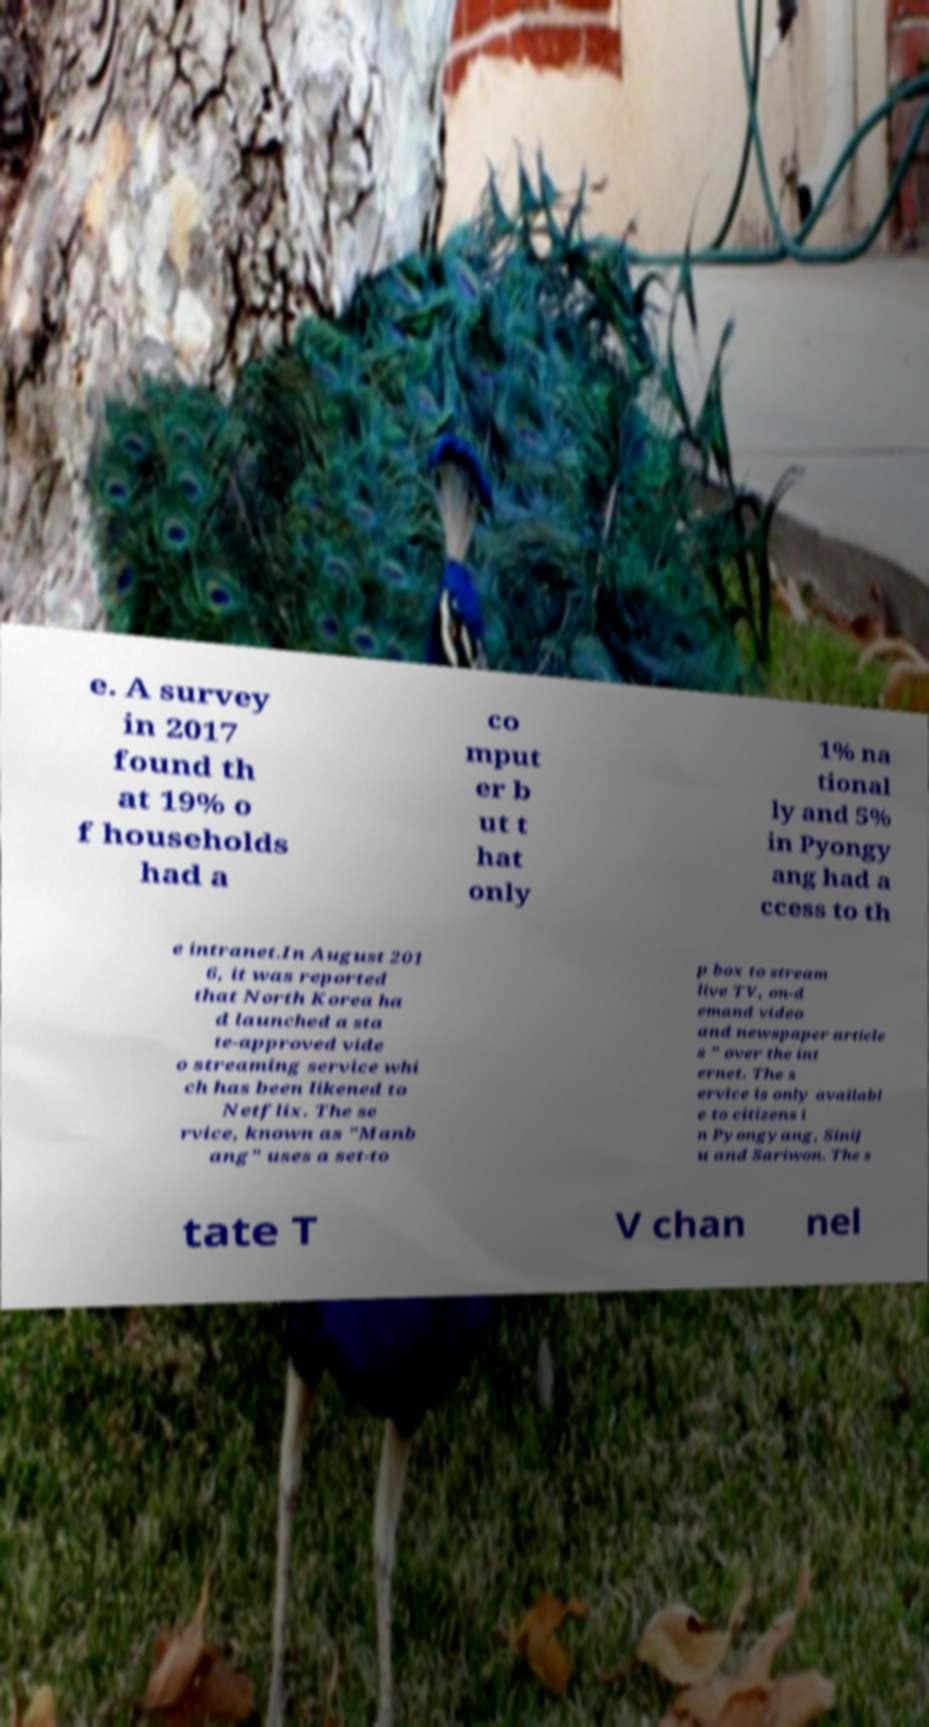I need the written content from this picture converted into text. Can you do that? e. A survey in 2017 found th at 19% o f households had a co mput er b ut t hat only 1% na tional ly and 5% in Pyongy ang had a ccess to th e intranet.In August 201 6, it was reported that North Korea ha d launched a sta te-approved vide o streaming service whi ch has been likened to Netflix. The se rvice, known as "Manb ang" uses a set-to p box to stream live TV, on-d emand video and newspaper article s " over the int ernet. The s ervice is only availabl e to citizens i n Pyongyang, Sinij u and Sariwon. The s tate T V chan nel 